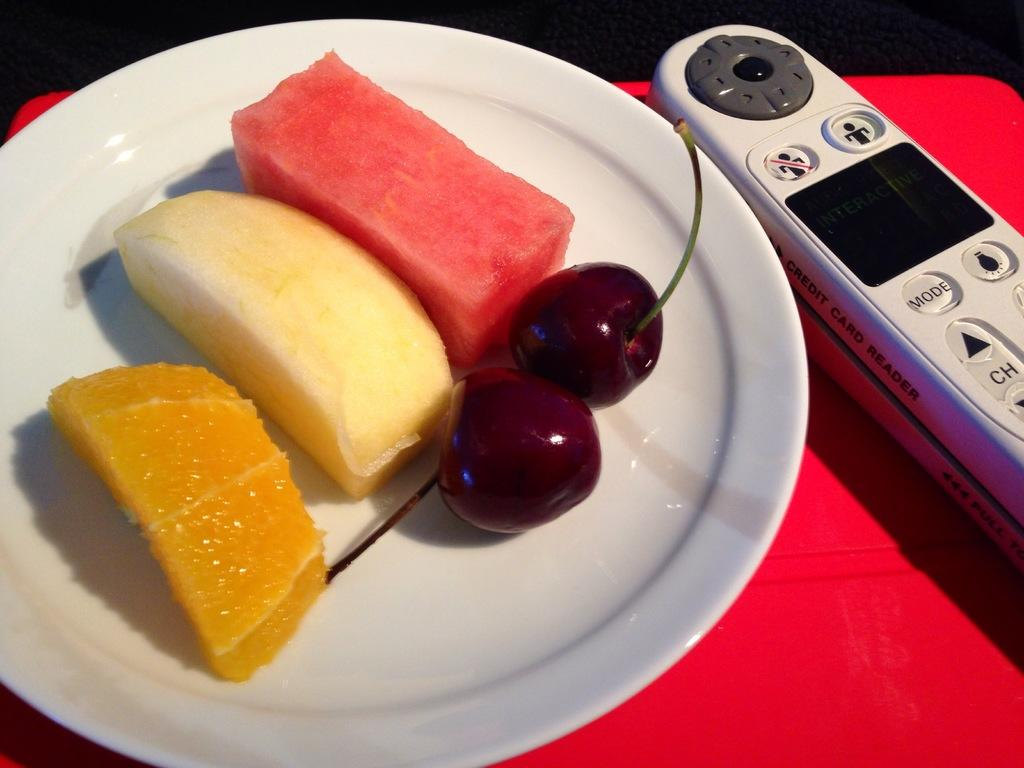<image>
Summarize the visual content of the image. A credit card reader next to a white saucer of fresh fruit. 